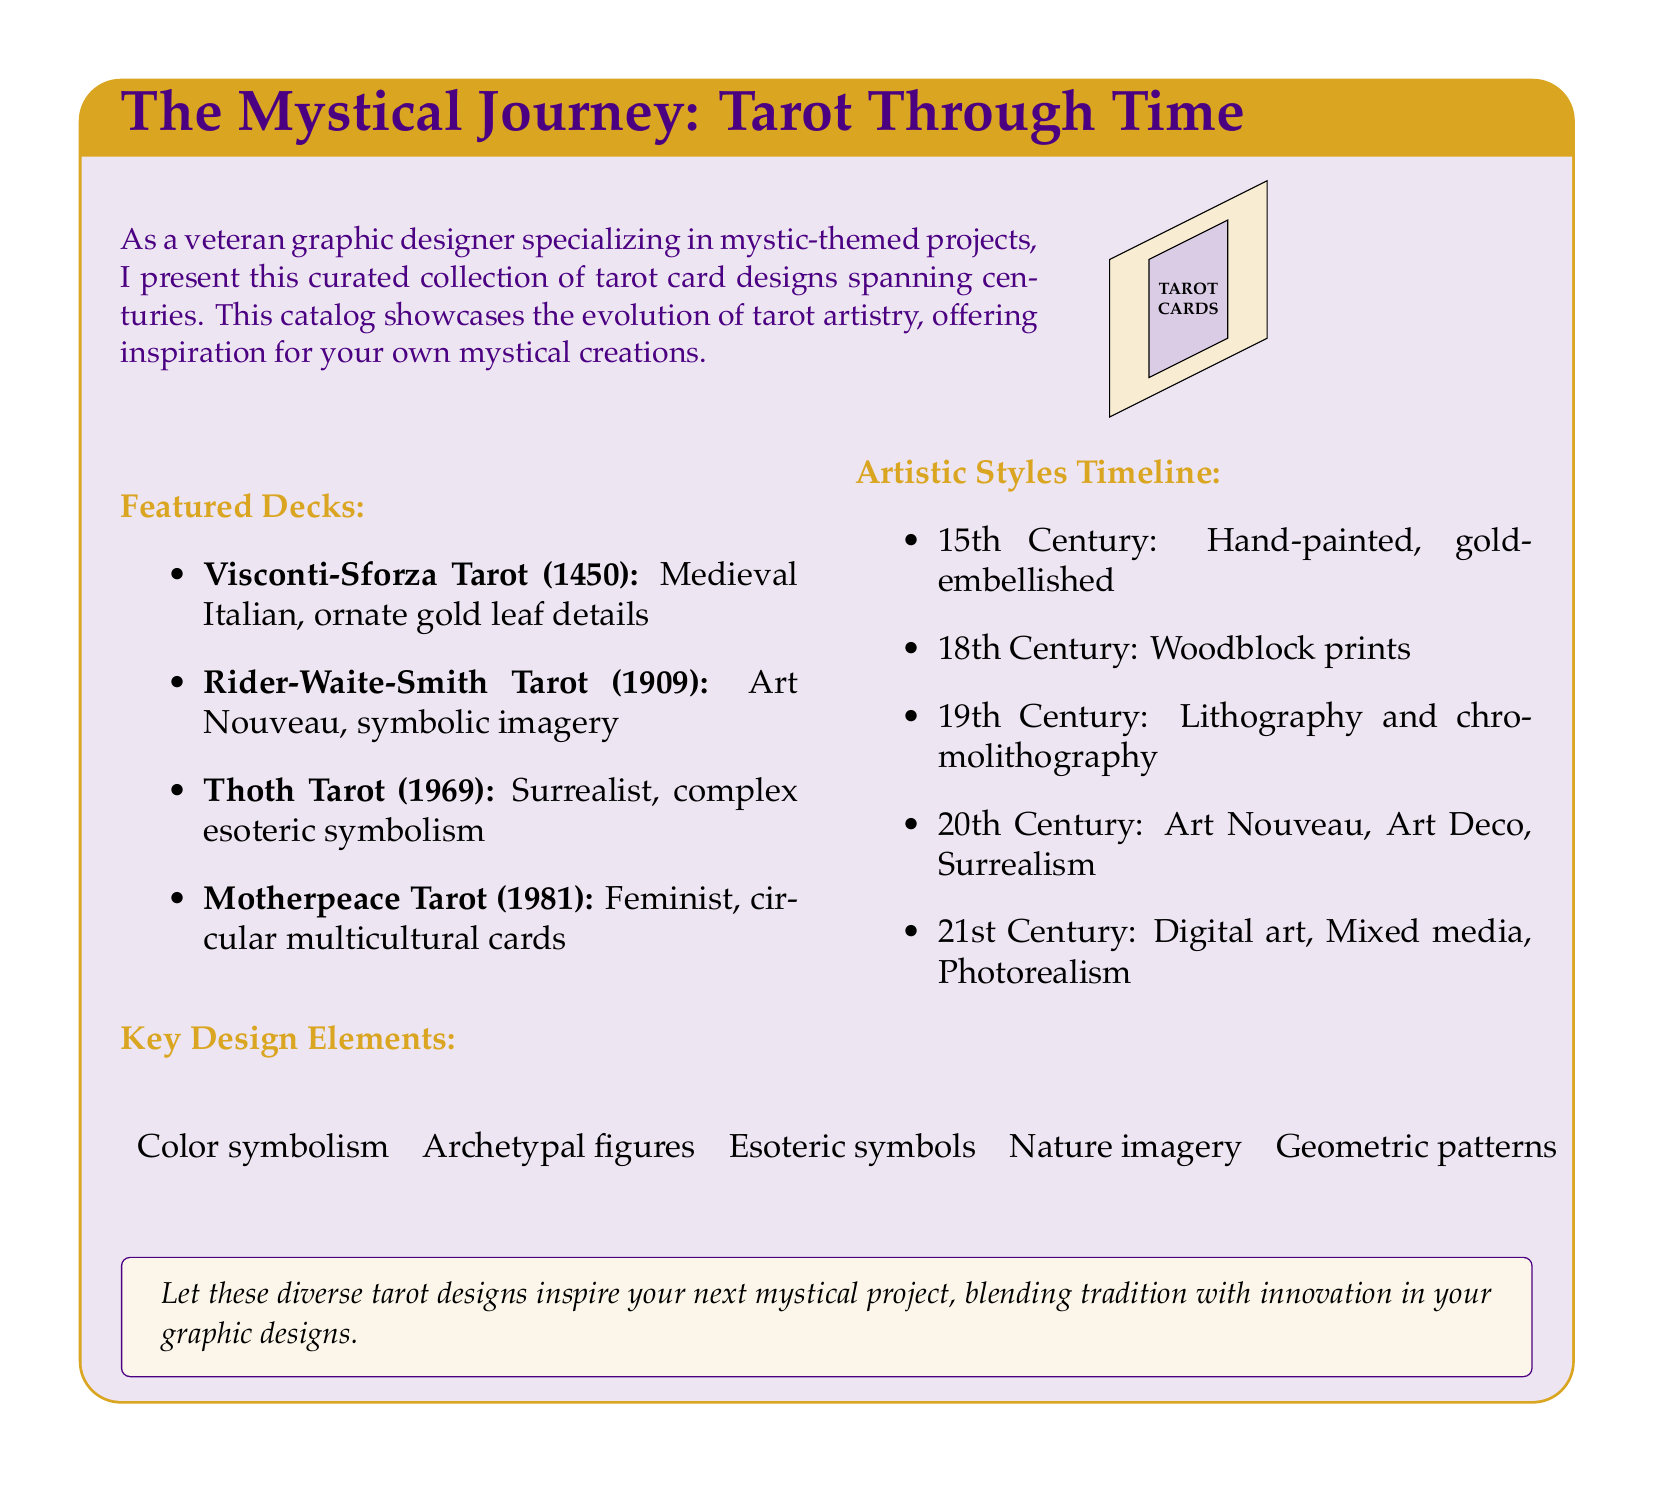What is the title of the document? The title is presented at the beginning of the document in a highlighted box.
Answer: The Mystical Journey: Tarot Through Time What year was the Rider-Waite-Smith Tarot created? The year is explicitly stated in the list of featured decks.
Answer: 1909 Which artistic style is associated with the Thoth Tarot? The artistic style is mentioned alongside the featured deck description.
Answer: Surrealist What does the 15th-century tarot design primarily feature? The design elements of the 15th century detail the style and embellishments used.
Answer: Hand-painted, gold-embellished Which tarot deck is noted for its circular multicultural cards? This deck is mentioned as one of the featured decks in the document.
Answer: Motherpeace Tarot How many artistic styles are listed in the timeline? The count of the listed styles can be derived from the timeline provided in the document.
Answer: Five What color is used for the header of the document? The color specification is mentioned in the definition section of the document.
Answer: Mystpurple Which design element is associated with nature imagery? The design elements are listed in the document emphasizing their thematic importance.
Answer: Nature imagery What is the primary medium used for the 18th-century tarot cards? The medium is specifically indicated in the artistic styles timeline.
Answer: Woodblock prints 